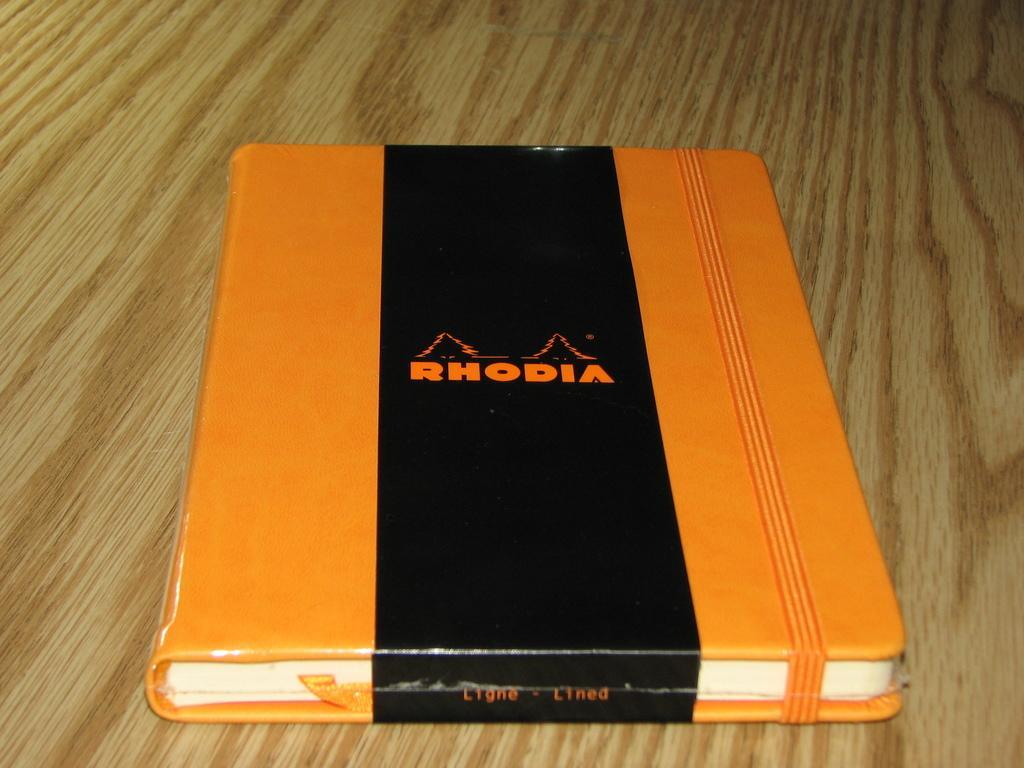<image>
Describe the image concisely. The bright orange color on the RHODIA journal is quite pretty. 